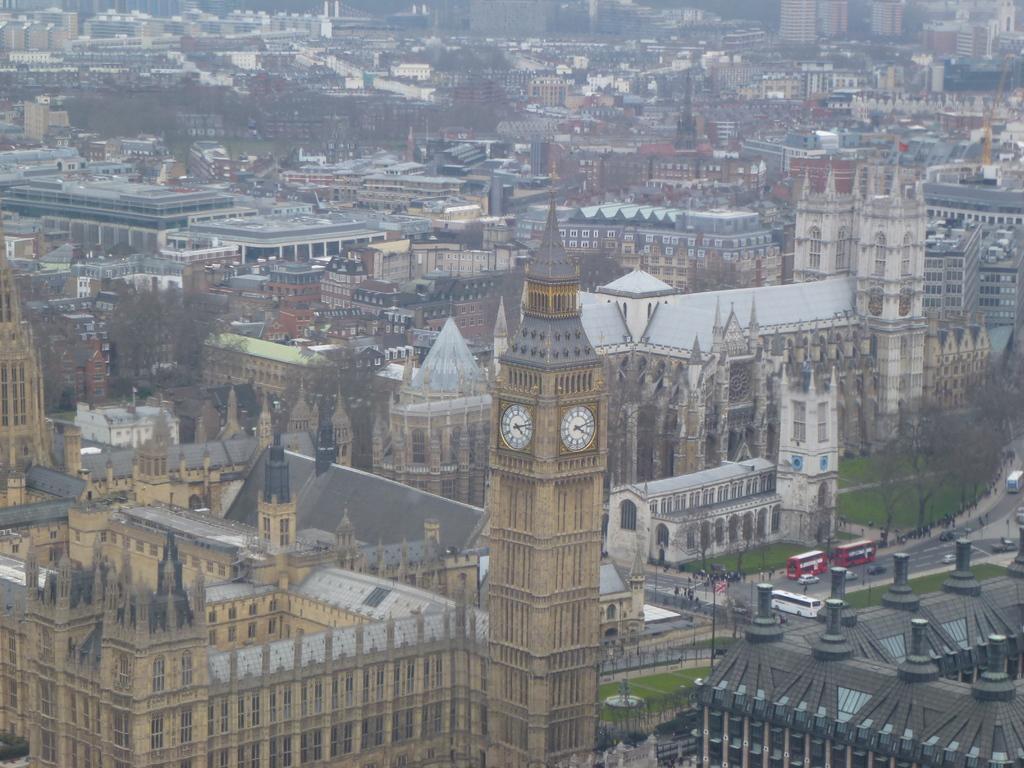How would you summarize this image in a sentence or two? In the image we can see some buildings and trees and grass and vehicles on the road. 